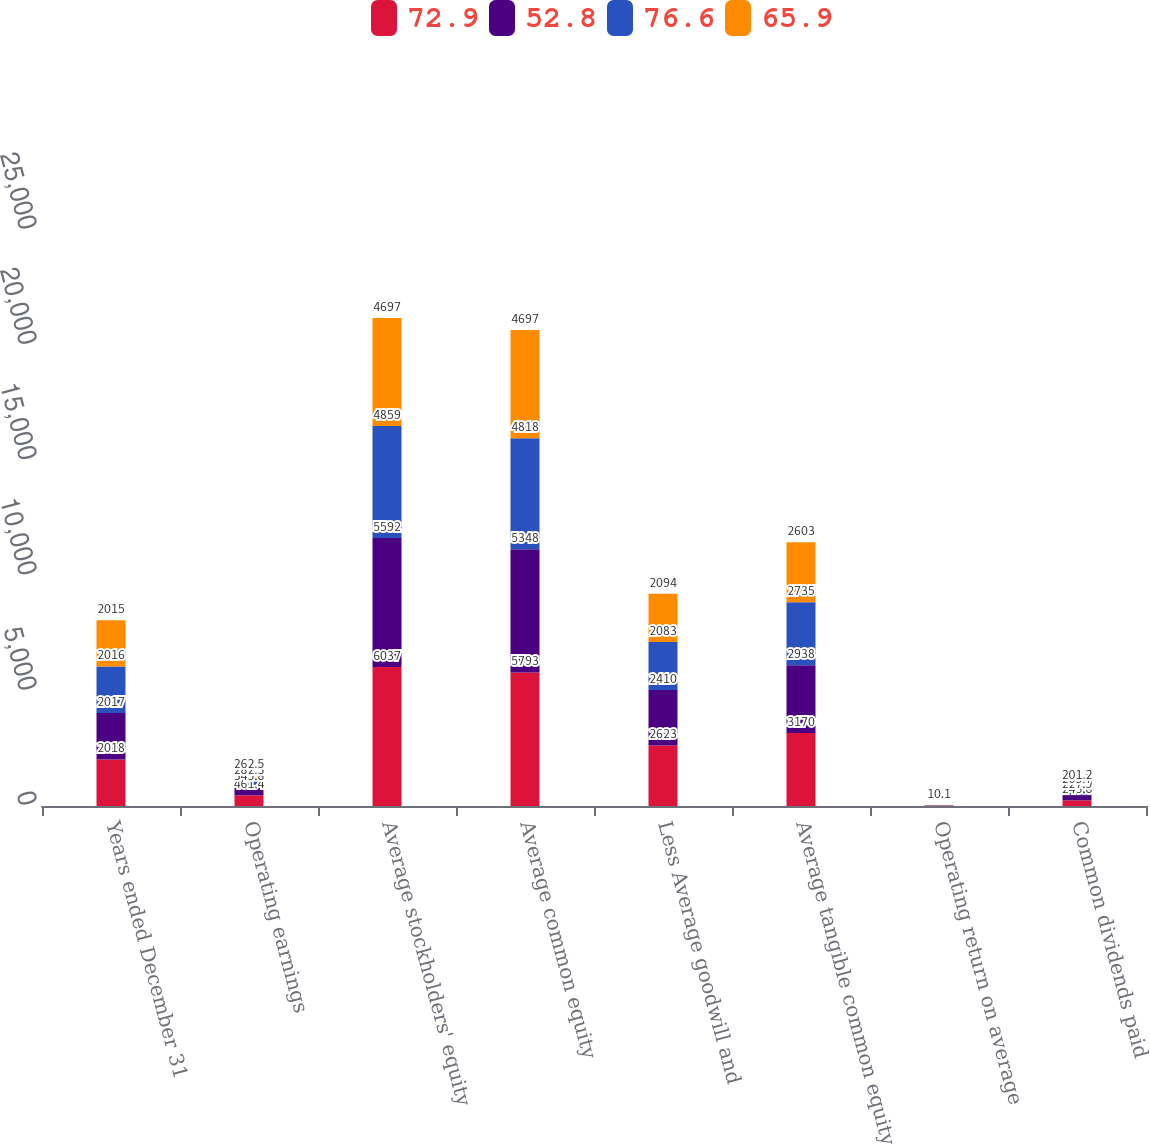<chart> <loc_0><loc_0><loc_500><loc_500><stacked_bar_chart><ecel><fcel>Years ended December 31<fcel>Operating earnings<fcel>Average stockholders' equity<fcel>Average common equity<fcel>Less Average goodwill and<fcel>Average tangible common equity<fcel>Operating return on average<fcel>Common dividends paid<nl><fcel>72.9<fcel>2018<fcel>461.4<fcel>6037<fcel>5793<fcel>2623<fcel>3170<fcel>14.6<fcel>243.8<nl><fcel>52.8<fcel>2017<fcel>345.8<fcel>5592<fcel>5348<fcel>2410<fcel>2938<fcel>11.8<fcel>227.9<nl><fcel>76.6<fcel>2016<fcel>282.3<fcel>4859<fcel>4818<fcel>2083<fcel>2735<fcel>10.3<fcel>205.7<nl><fcel>65.9<fcel>2015<fcel>262.5<fcel>4697<fcel>4697<fcel>2094<fcel>2603<fcel>10.1<fcel>201.2<nl></chart> 